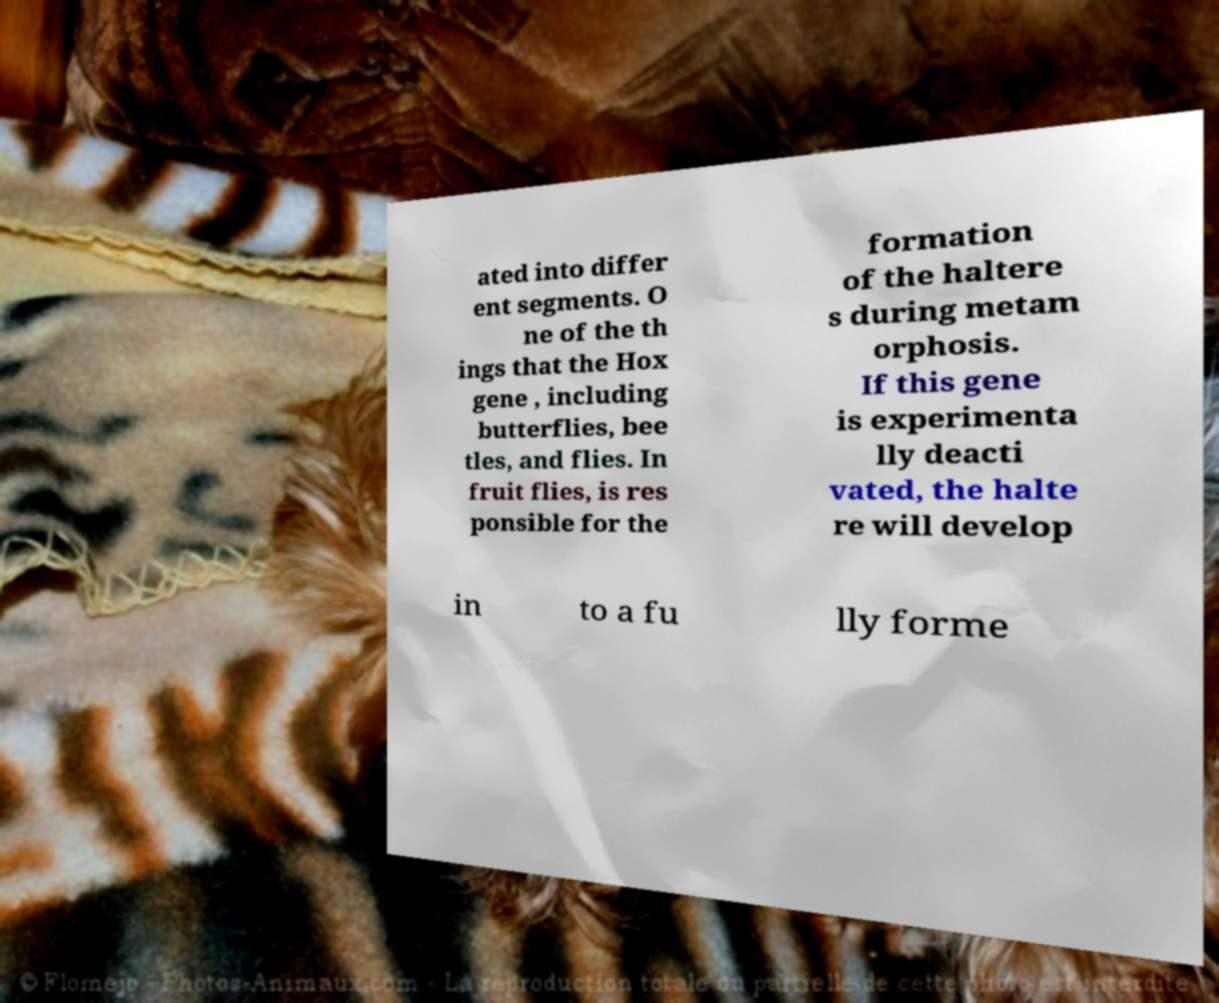Please read and relay the text visible in this image. What does it say? ated into differ ent segments. O ne of the th ings that the Hox gene , including butterflies, bee tles, and flies. In fruit flies, is res ponsible for the formation of the haltere s during metam orphosis. If this gene is experimenta lly deacti vated, the halte re will develop in to a fu lly forme 